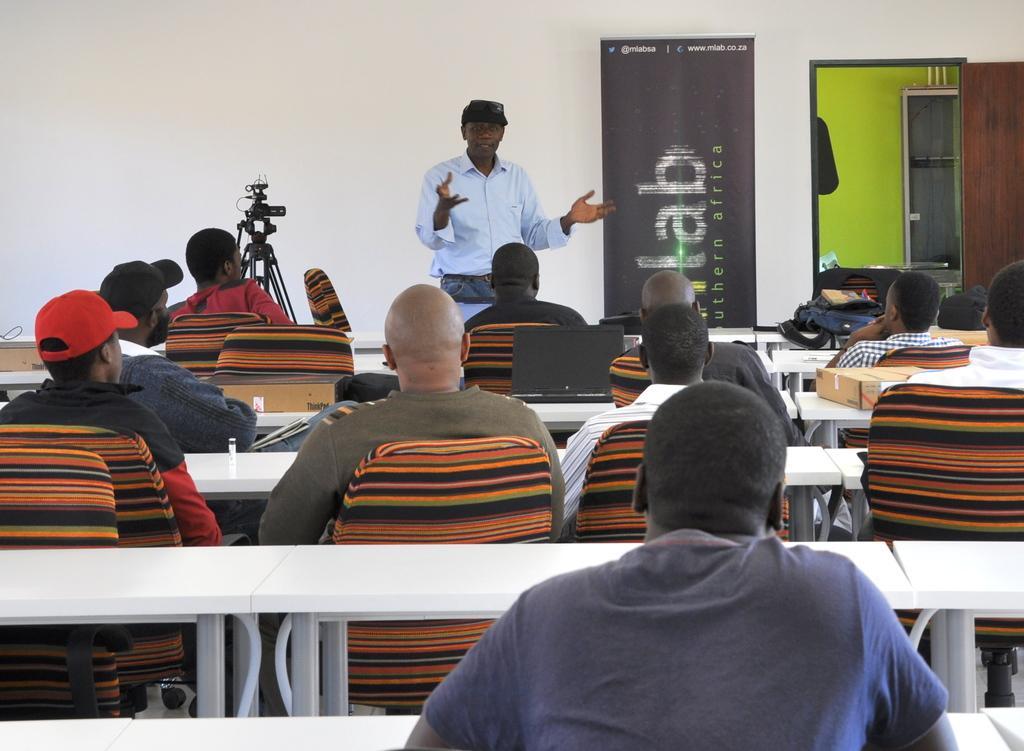How would you summarize this image in a sentence or two? In this picture there are several people sitting on chairs and in front of them there is a white table ,in front of them there is guy explaining them. In the background there are few posters. 